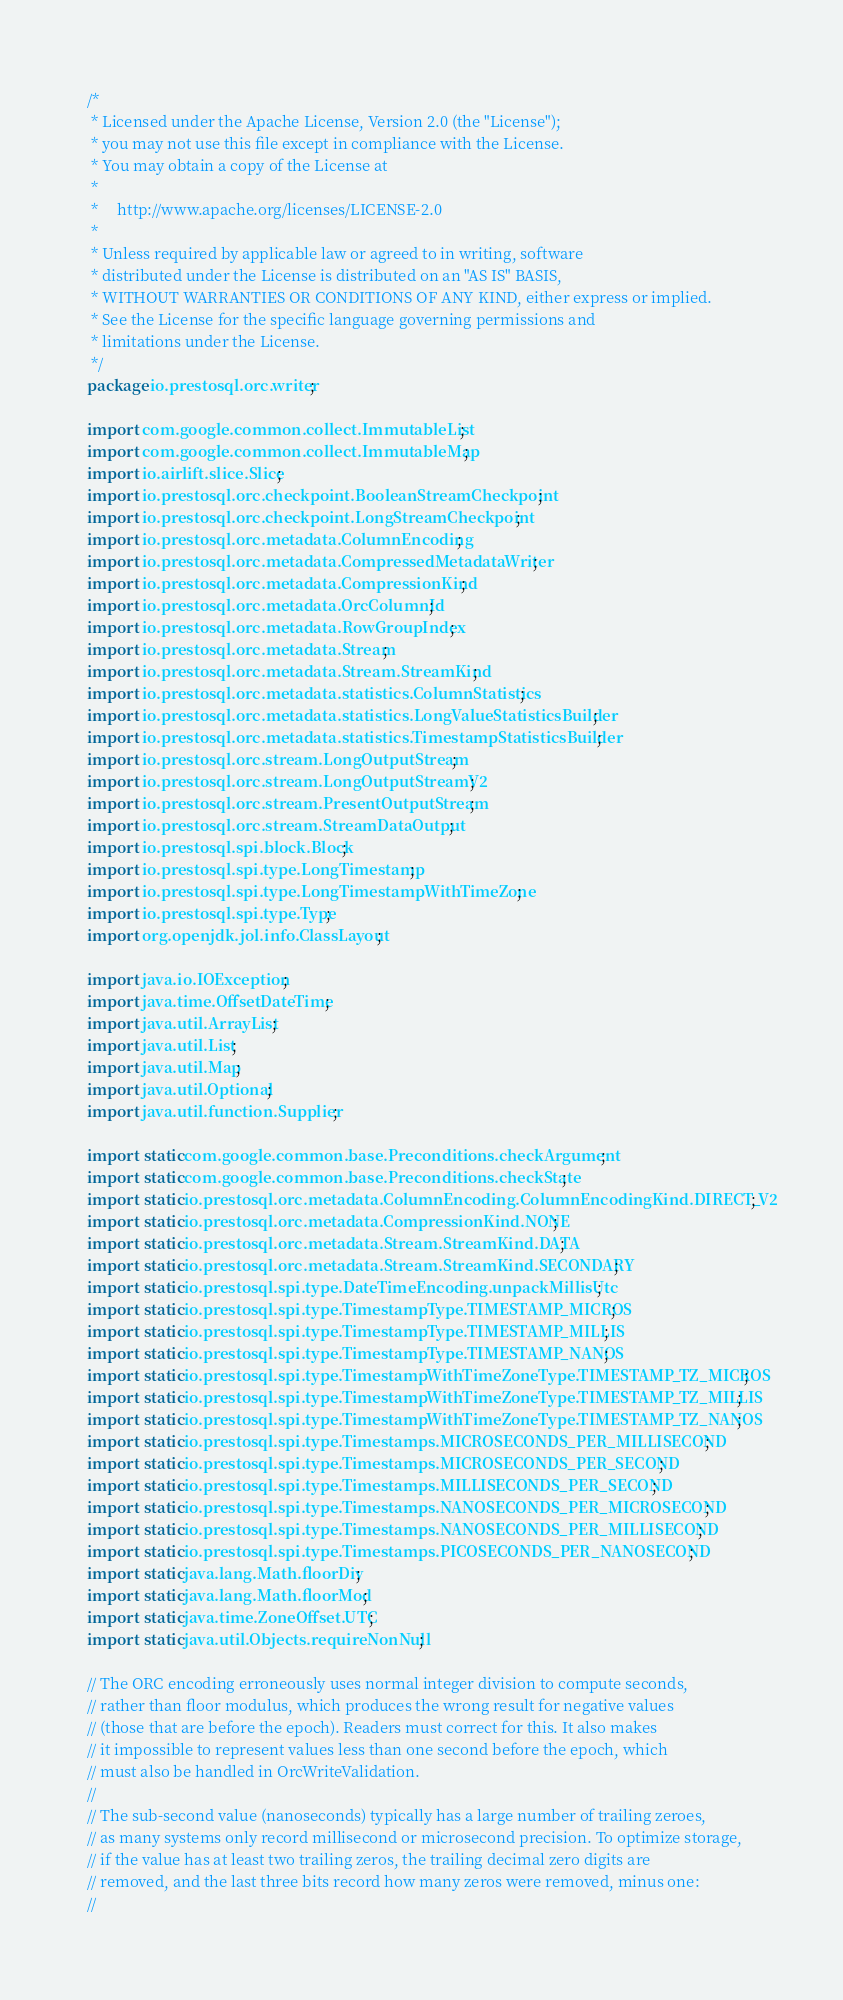<code> <loc_0><loc_0><loc_500><loc_500><_Java_>/*
 * Licensed under the Apache License, Version 2.0 (the "License");
 * you may not use this file except in compliance with the License.
 * You may obtain a copy of the License at
 *
 *     http://www.apache.org/licenses/LICENSE-2.0
 *
 * Unless required by applicable law or agreed to in writing, software
 * distributed under the License is distributed on an "AS IS" BASIS,
 * WITHOUT WARRANTIES OR CONDITIONS OF ANY KIND, either express or implied.
 * See the License for the specific language governing permissions and
 * limitations under the License.
 */
package io.prestosql.orc.writer;

import com.google.common.collect.ImmutableList;
import com.google.common.collect.ImmutableMap;
import io.airlift.slice.Slice;
import io.prestosql.orc.checkpoint.BooleanStreamCheckpoint;
import io.prestosql.orc.checkpoint.LongStreamCheckpoint;
import io.prestosql.orc.metadata.ColumnEncoding;
import io.prestosql.orc.metadata.CompressedMetadataWriter;
import io.prestosql.orc.metadata.CompressionKind;
import io.prestosql.orc.metadata.OrcColumnId;
import io.prestosql.orc.metadata.RowGroupIndex;
import io.prestosql.orc.metadata.Stream;
import io.prestosql.orc.metadata.Stream.StreamKind;
import io.prestosql.orc.metadata.statistics.ColumnStatistics;
import io.prestosql.orc.metadata.statistics.LongValueStatisticsBuilder;
import io.prestosql.orc.metadata.statistics.TimestampStatisticsBuilder;
import io.prestosql.orc.stream.LongOutputStream;
import io.prestosql.orc.stream.LongOutputStreamV2;
import io.prestosql.orc.stream.PresentOutputStream;
import io.prestosql.orc.stream.StreamDataOutput;
import io.prestosql.spi.block.Block;
import io.prestosql.spi.type.LongTimestamp;
import io.prestosql.spi.type.LongTimestampWithTimeZone;
import io.prestosql.spi.type.Type;
import org.openjdk.jol.info.ClassLayout;

import java.io.IOException;
import java.time.OffsetDateTime;
import java.util.ArrayList;
import java.util.List;
import java.util.Map;
import java.util.Optional;
import java.util.function.Supplier;

import static com.google.common.base.Preconditions.checkArgument;
import static com.google.common.base.Preconditions.checkState;
import static io.prestosql.orc.metadata.ColumnEncoding.ColumnEncodingKind.DIRECT_V2;
import static io.prestosql.orc.metadata.CompressionKind.NONE;
import static io.prestosql.orc.metadata.Stream.StreamKind.DATA;
import static io.prestosql.orc.metadata.Stream.StreamKind.SECONDARY;
import static io.prestosql.spi.type.DateTimeEncoding.unpackMillisUtc;
import static io.prestosql.spi.type.TimestampType.TIMESTAMP_MICROS;
import static io.prestosql.spi.type.TimestampType.TIMESTAMP_MILLIS;
import static io.prestosql.spi.type.TimestampType.TIMESTAMP_NANOS;
import static io.prestosql.spi.type.TimestampWithTimeZoneType.TIMESTAMP_TZ_MICROS;
import static io.prestosql.spi.type.TimestampWithTimeZoneType.TIMESTAMP_TZ_MILLIS;
import static io.prestosql.spi.type.TimestampWithTimeZoneType.TIMESTAMP_TZ_NANOS;
import static io.prestosql.spi.type.Timestamps.MICROSECONDS_PER_MILLISECOND;
import static io.prestosql.spi.type.Timestamps.MICROSECONDS_PER_SECOND;
import static io.prestosql.spi.type.Timestamps.MILLISECONDS_PER_SECOND;
import static io.prestosql.spi.type.Timestamps.NANOSECONDS_PER_MICROSECOND;
import static io.prestosql.spi.type.Timestamps.NANOSECONDS_PER_MILLISECOND;
import static io.prestosql.spi.type.Timestamps.PICOSECONDS_PER_NANOSECOND;
import static java.lang.Math.floorDiv;
import static java.lang.Math.floorMod;
import static java.time.ZoneOffset.UTC;
import static java.util.Objects.requireNonNull;

// The ORC encoding erroneously uses normal integer division to compute seconds,
// rather than floor modulus, which produces the wrong result for negative values
// (those that are before the epoch). Readers must correct for this. It also makes
// it impossible to represent values less than one second before the epoch, which
// must also be handled in OrcWriteValidation.
//
// The sub-second value (nanoseconds) typically has a large number of trailing zeroes,
// as many systems only record millisecond or microsecond precision. To optimize storage,
// if the value has at least two trailing zeros, the trailing decimal zero digits are
// removed, and the last three bits record how many zeros were removed, minus one:
//</code> 